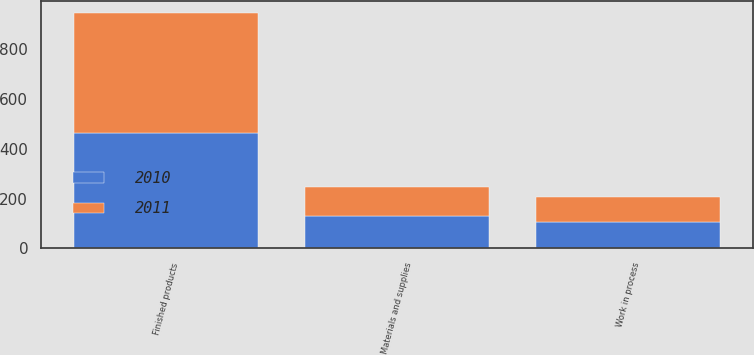<chart> <loc_0><loc_0><loc_500><loc_500><stacked_bar_chart><ecel><fcel>Materials and supplies<fcel>Work in process<fcel>Finished products<nl><fcel>2010<fcel>130.8<fcel>105.6<fcel>463.5<nl><fcel>2011<fcel>116.8<fcel>101<fcel>483.8<nl></chart> 